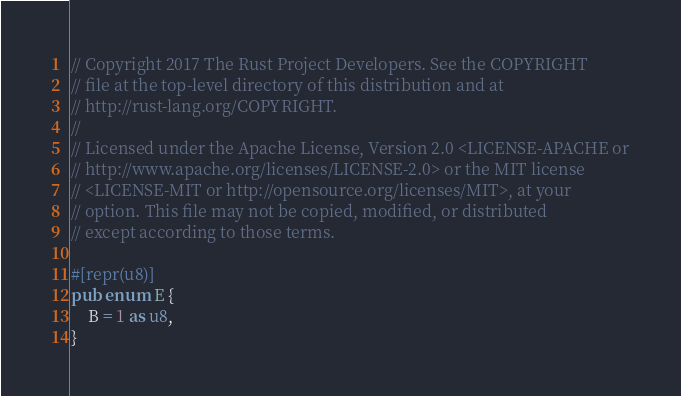<code> <loc_0><loc_0><loc_500><loc_500><_Rust_>// Copyright 2017 The Rust Project Developers. See the COPYRIGHT
// file at the top-level directory of this distribution and at
// http://rust-lang.org/COPYRIGHT.
//
// Licensed under the Apache License, Version 2.0 <LICENSE-APACHE or
// http://www.apache.org/licenses/LICENSE-2.0> or the MIT license
// <LICENSE-MIT or http://opensource.org/licenses/MIT>, at your
// option. This file may not be copied, modified, or distributed
// except according to those terms.

#[repr(u8)]
pub enum E {
    B = 1 as u8,
}</code> 